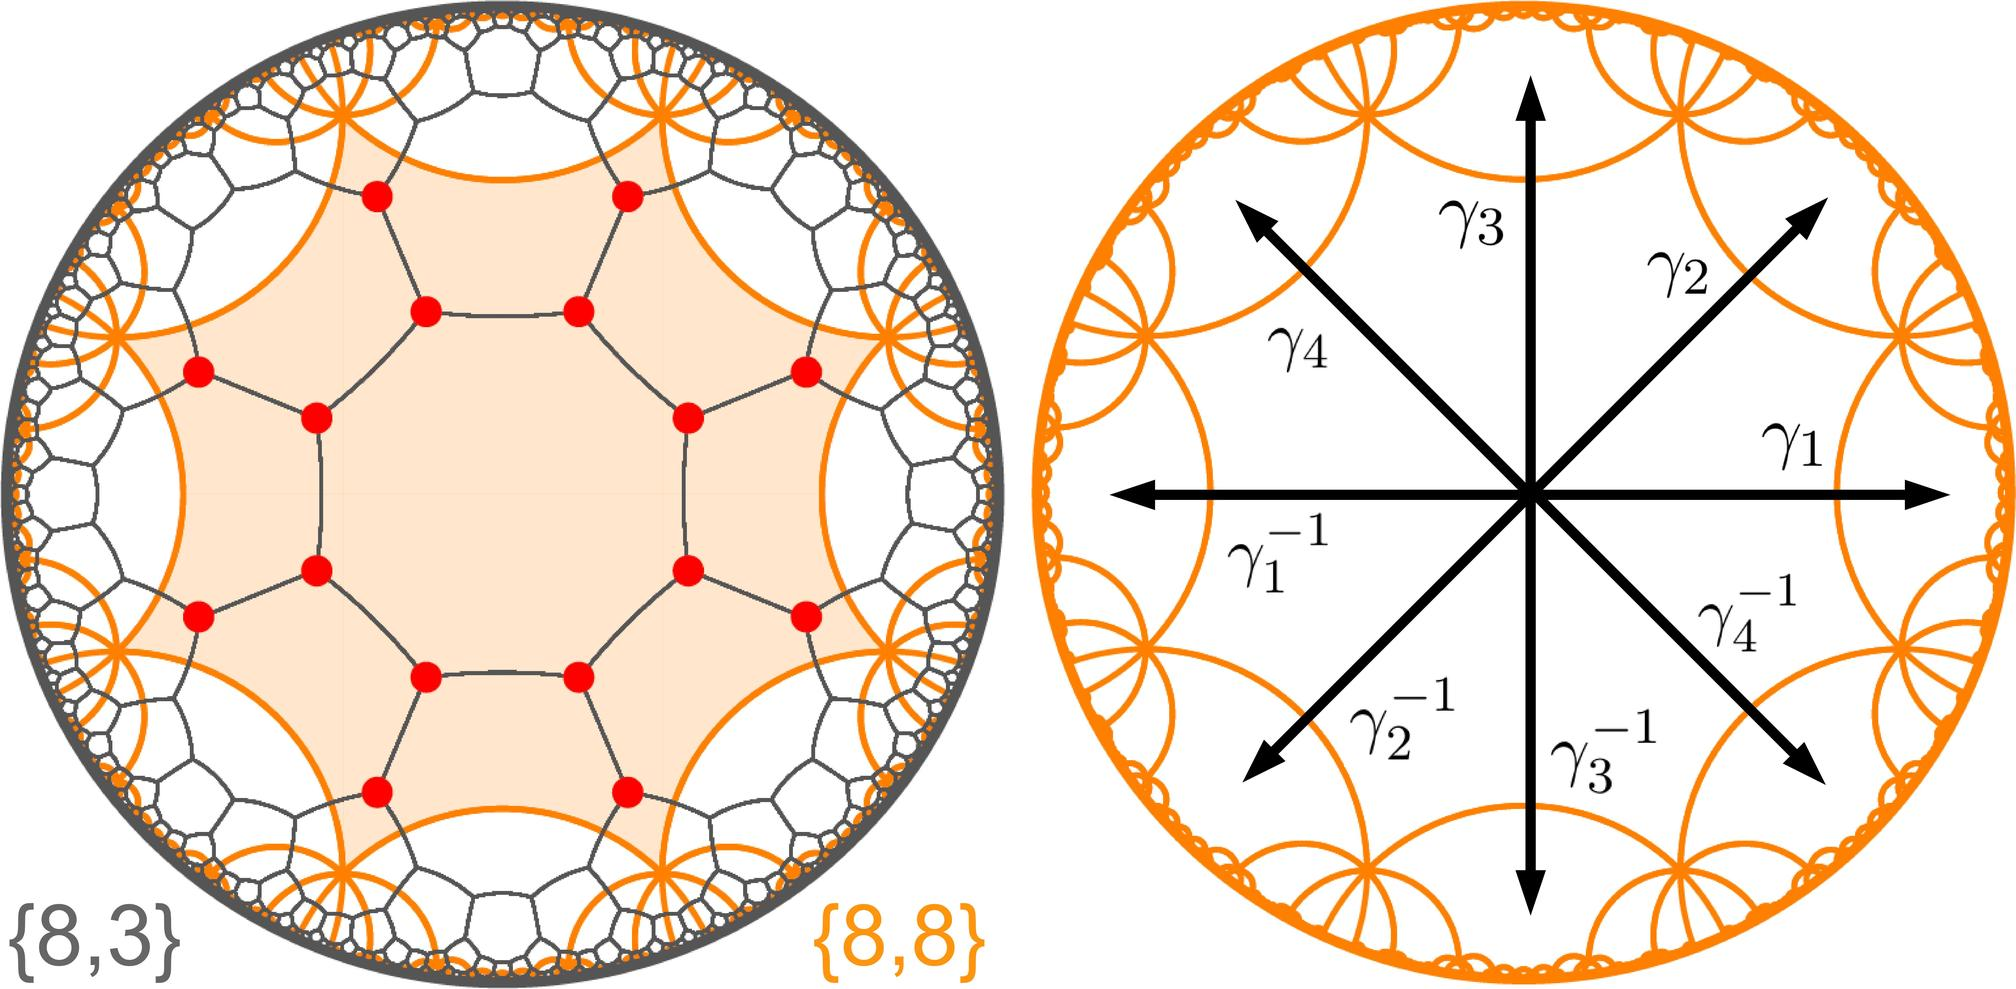Can you explain why the roots \(\gamma_1, \gamma_2, \gamma_3, \gamma_4\) are shown with their negatives on this complex circle? The roots \(\gamma_1, \gamma_2, \gamma_3, \gamma_4\) and their negatives are depicted to illustrate that for every root of the polynomial, its negative is also a root. This reflects a specific property of polynomials, especially those that are symmetric with respect to the origin of the complex plane. Such representations help in understanding the holistic nature of polynomial roots and their symmetrical distribution, particularly useful in fields like signal processing and control systems where such patterns are critical. 